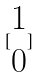<formula> <loc_0><loc_0><loc_500><loc_500>[ \begin{matrix} 1 \\ 0 \end{matrix} ]</formula> 